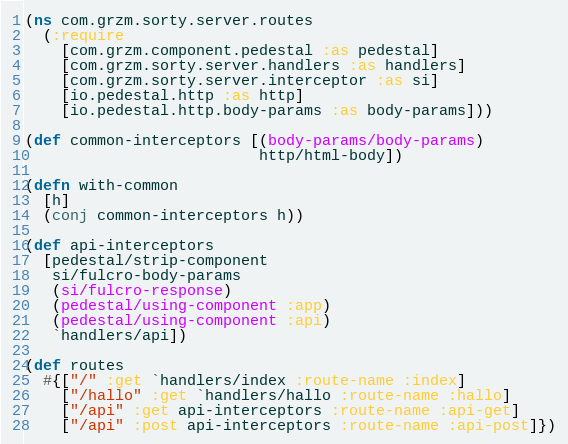<code> <loc_0><loc_0><loc_500><loc_500><_Clojure_>(ns com.grzm.sorty.server.routes
  (:require
    [com.grzm.component.pedestal :as pedestal]
    [com.grzm.sorty.server.handlers :as handlers]
    [com.grzm.sorty.server.interceptor :as si]
    [io.pedestal.http :as http]
    [io.pedestal.http.body-params :as body-params]))

(def common-interceptors [(body-params/body-params)
                          http/html-body])

(defn with-common
  [h]
  (conj common-interceptors h))

(def api-interceptors
  [pedestal/strip-component
   si/fulcro-body-params
   (si/fulcro-response)
   (pedestal/using-component :app)
   (pedestal/using-component :api)
   `handlers/api])

(def routes
  #{["/" :get `handlers/index :route-name :index]
    ["/hallo" :get `handlers/hallo :route-name :hallo]
    ["/api" :get api-interceptors :route-name :api-get]
    ["/api" :post api-interceptors :route-name :api-post]})
</code> 